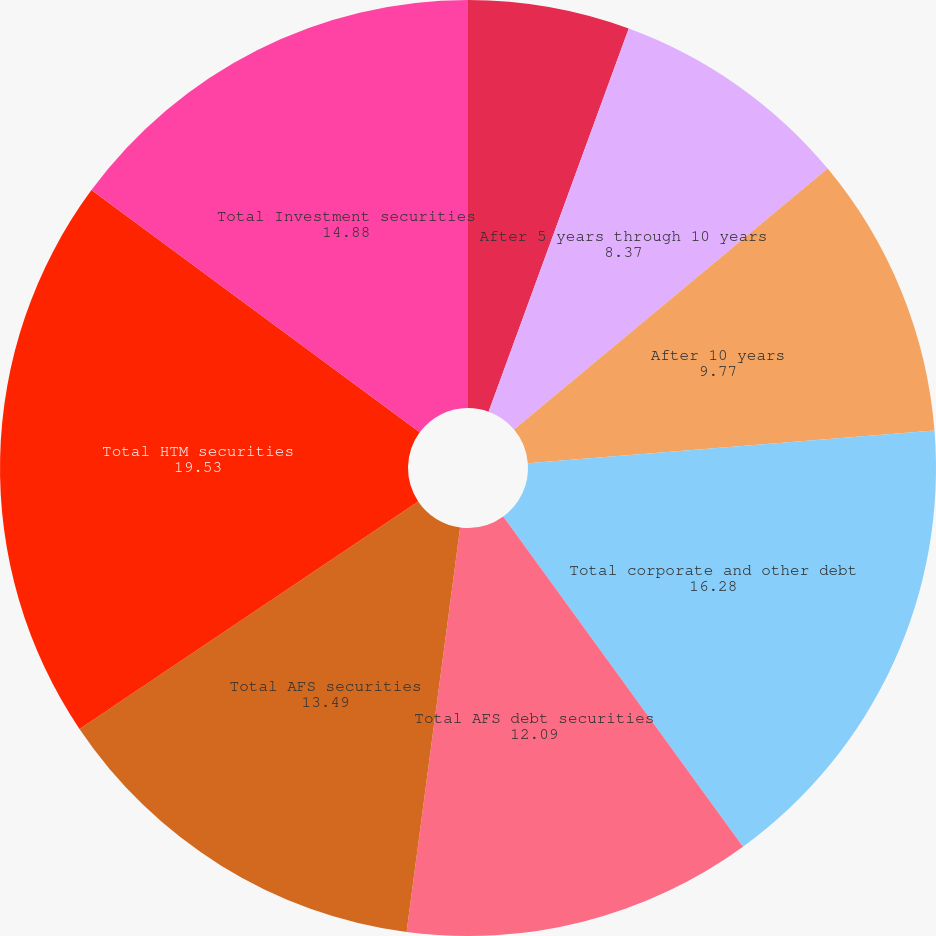Convert chart. <chart><loc_0><loc_0><loc_500><loc_500><pie_chart><fcel>After 1 year through 5 years<fcel>After 5 years through 10 years<fcel>After 10 years<fcel>Total corporate and other debt<fcel>Total AFS debt securities<fcel>Total AFS securities<fcel>Total HTM securities<fcel>Total Investment securities<nl><fcel>5.58%<fcel>8.37%<fcel>9.77%<fcel>16.28%<fcel>12.09%<fcel>13.49%<fcel>19.53%<fcel>14.88%<nl></chart> 